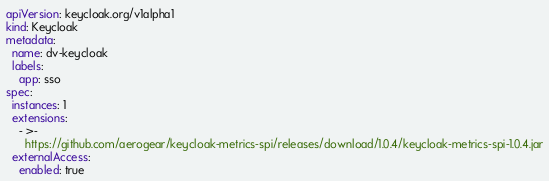Convert code to text. <code><loc_0><loc_0><loc_500><loc_500><_YAML_>apiVersion: keycloak.org/v1alpha1
kind: Keycloak
metadata:
  name: dv-keycloak
  labels:
    app: sso
spec:
  instances: 1
  extensions:
    - >-
      https://github.com/aerogear/keycloak-metrics-spi/releases/download/1.0.4/keycloak-metrics-spi-1.0.4.jar
  externalAccess:
    enabled: true
</code> 